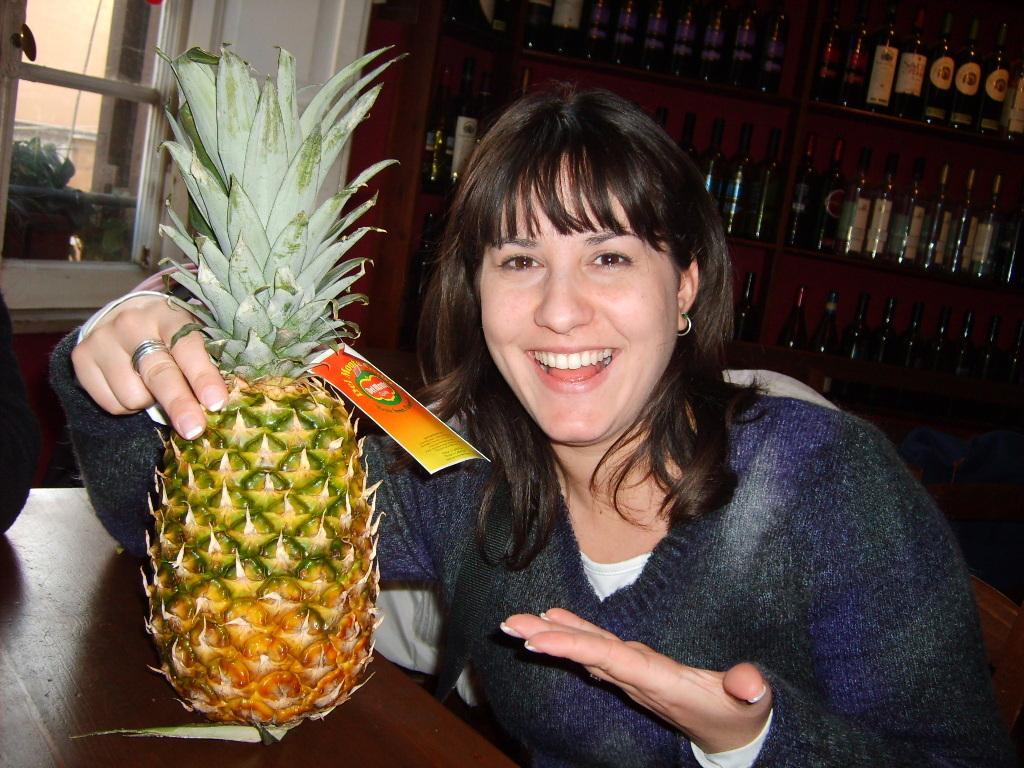Please provide a concise description of this image. In this image we can see a woman sitting on the chair and holding a pineapple that is placed on the table. In the background we can see windows and beverage bottles arranged in the cupboards. 